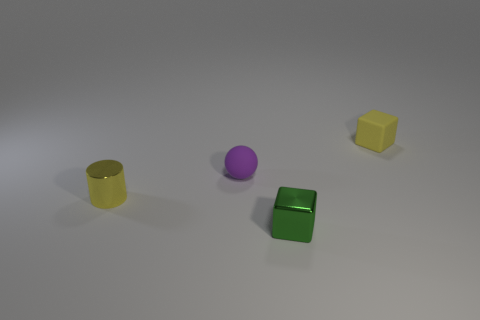How many things are both right of the cylinder and left of the small yellow rubber cube?
Provide a succinct answer. 2. Are there fewer matte balls that are on the left side of the tiny yellow metal thing than yellow rubber objects?
Offer a terse response. Yes. Are there any other gray metal blocks that have the same size as the metal cube?
Give a very brief answer. No. The small block that is the same material as the tiny ball is what color?
Provide a succinct answer. Yellow. What number of matte cubes are in front of the small yellow thing on the right side of the green object?
Your answer should be compact. 0. There is a small object that is behind the metallic cube and on the right side of the small purple object; what material is it?
Make the answer very short. Rubber. Does the small yellow thing that is to the left of the tiny purple thing have the same shape as the purple thing?
Your response must be concise. No. Are there fewer big metal blocks than green shiny things?
Offer a very short reply. Yes. How many rubber balls have the same color as the tiny metallic block?
Your answer should be very brief. 0. There is a small block that is the same color as the small cylinder; what material is it?
Offer a very short reply. Rubber. 